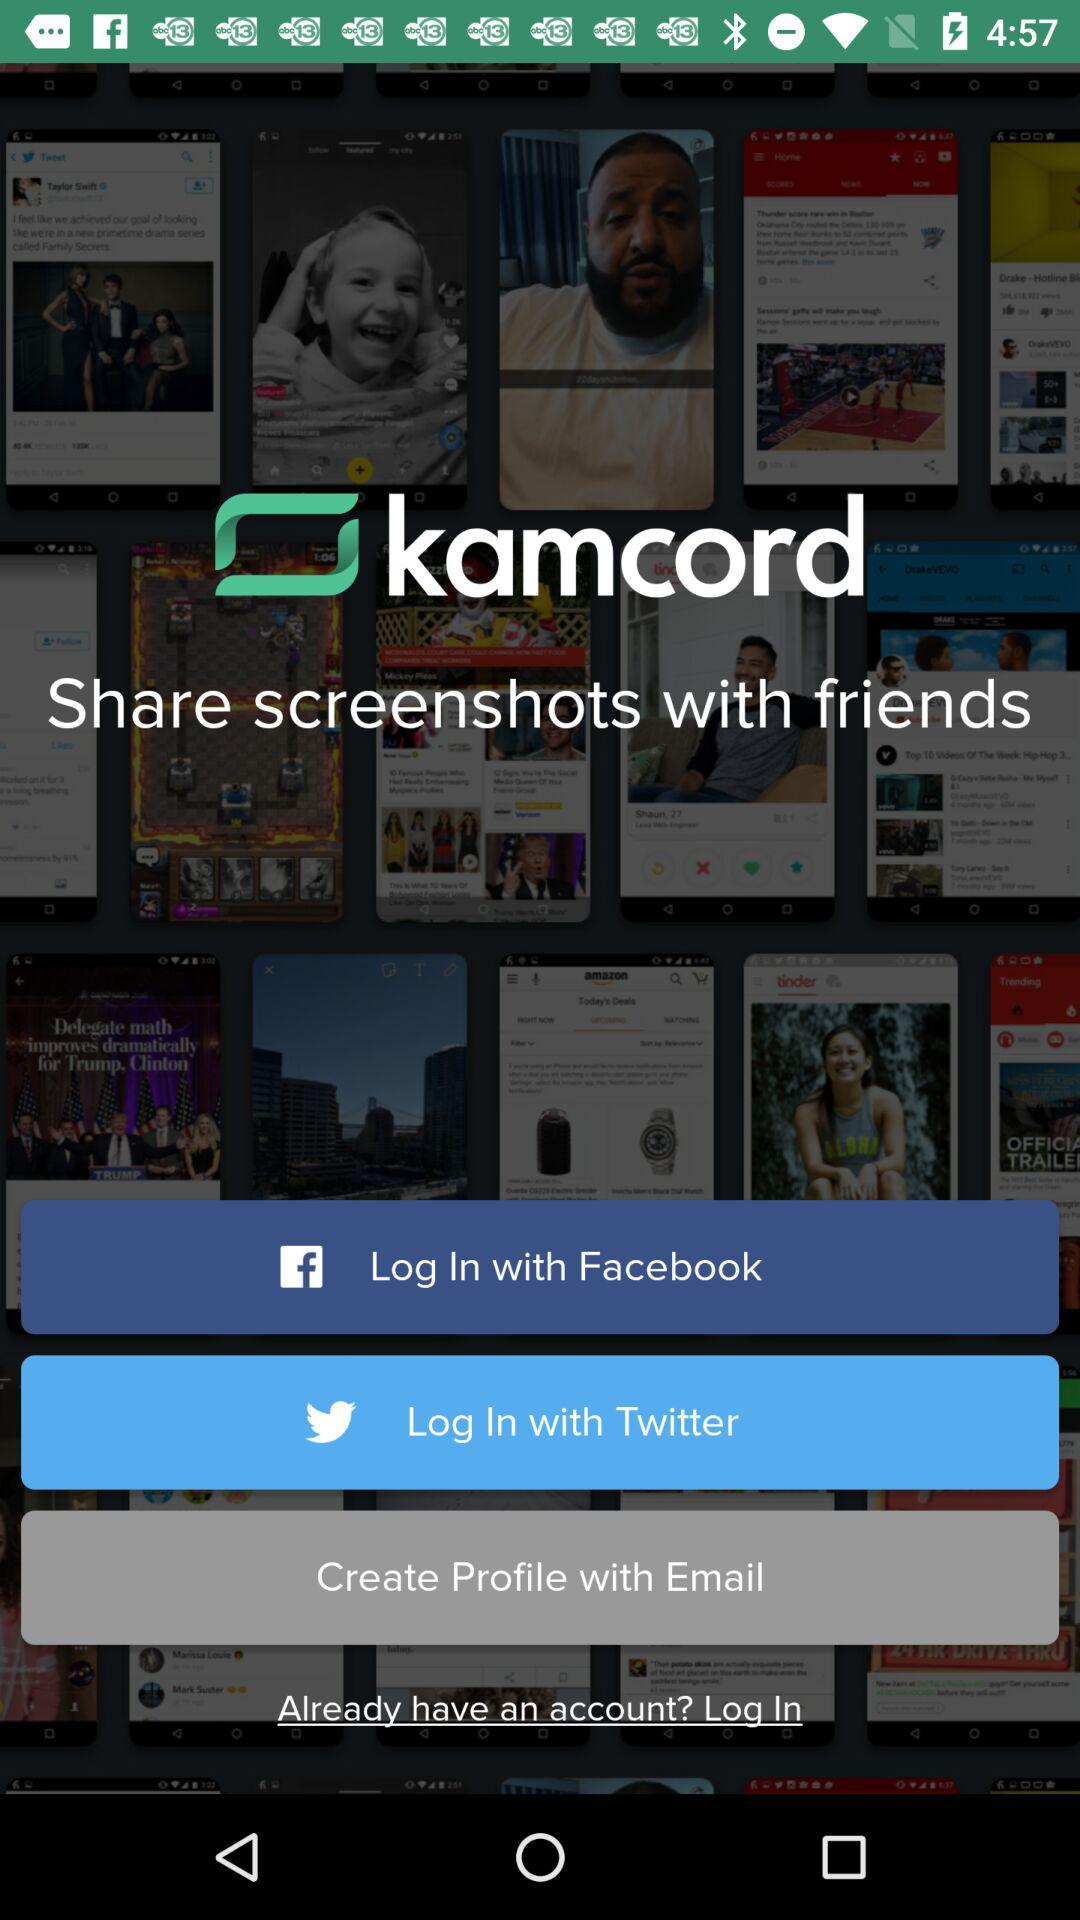With which means can the user create a profile? The user can create a profile with "Email". 